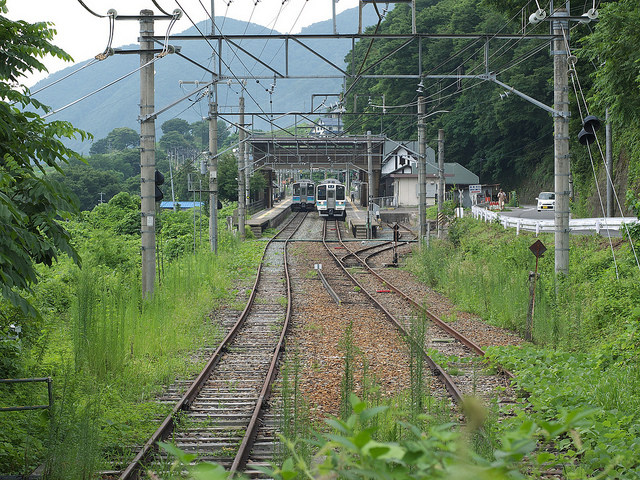Can you describe the environment surrounding the train tracks? Certainly! The train tracks in the image run through a lush, green area that seems semi-rural. There's plenty of vegetation on both sides of the tracks, and the presence of mountains in the background suggests that this might be a hilly or mountainous region. The overcast sky gives the scene a calm, temperate look. 